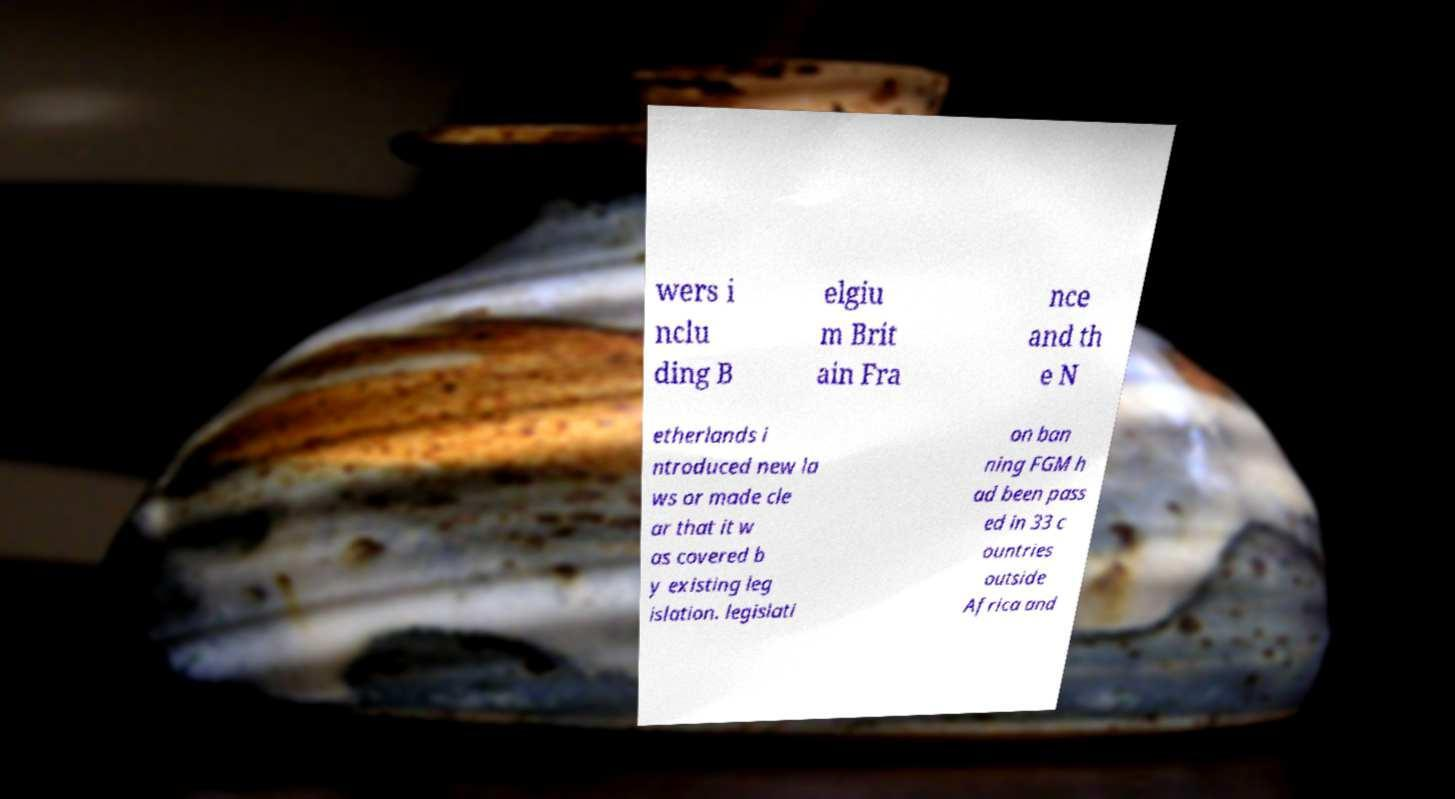I need the written content from this picture converted into text. Can you do that? wers i nclu ding B elgiu m Brit ain Fra nce and th e N etherlands i ntroduced new la ws or made cle ar that it w as covered b y existing leg islation. legislati on ban ning FGM h ad been pass ed in 33 c ountries outside Africa and 